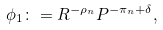<formula> <loc_0><loc_0><loc_500><loc_500>\phi _ { 1 } \colon = R ^ { - \rho _ { n } } P ^ { - \pi _ { n } + \delta } ,</formula> 